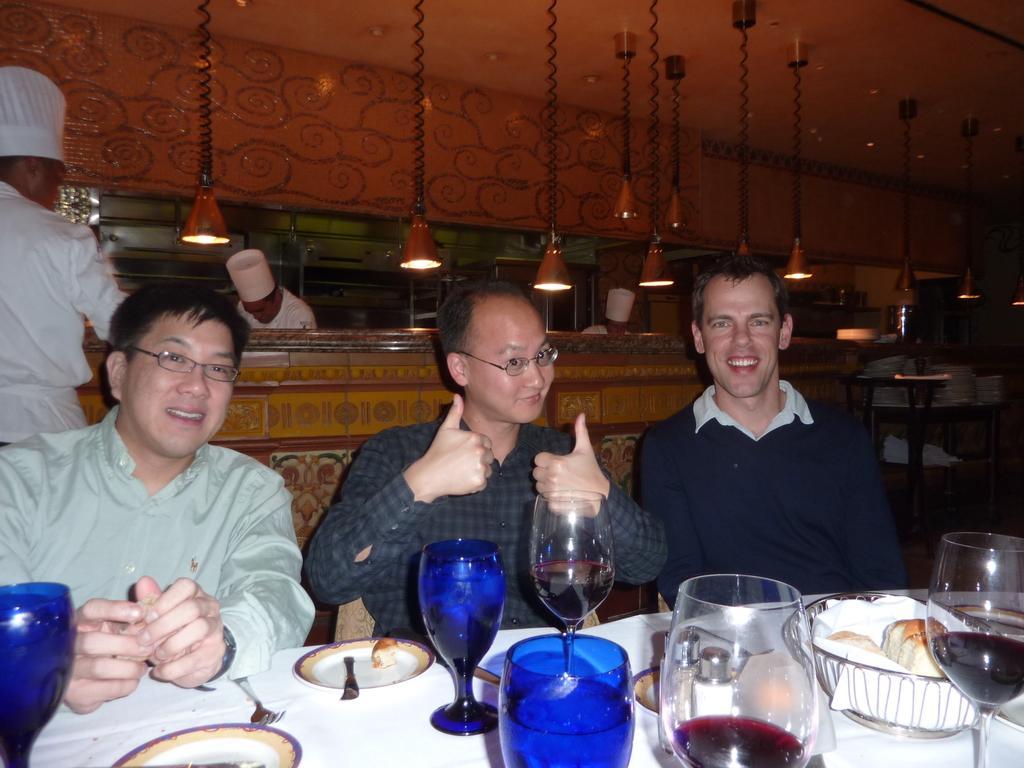Could you give a brief overview of what you see in this image? This 3 persons are highlighted in this picture. This 3 persons are sitting on a chair, in-front of this 3 persons there is a table, on a table there is a plate, fork and glasses. For this 2 persons are standing. This 2 persons wore a hat. Far on a tray there are number of plates. 